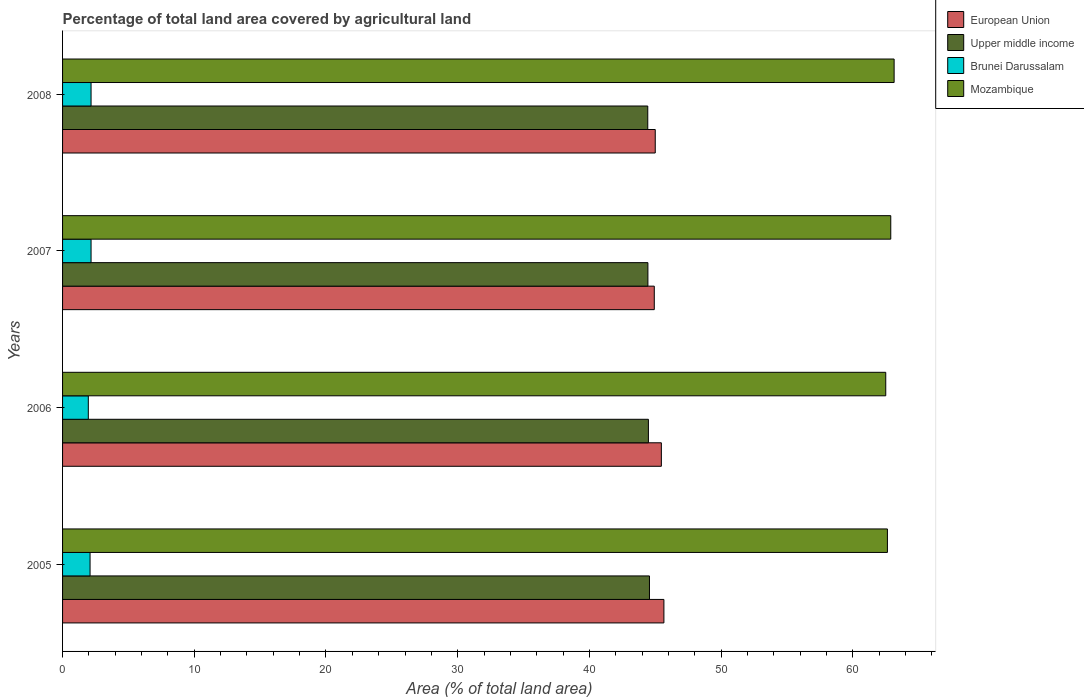How many different coloured bars are there?
Make the answer very short. 4. How many bars are there on the 1st tick from the top?
Make the answer very short. 4. How many bars are there on the 3rd tick from the bottom?
Offer a terse response. 4. In how many cases, is the number of bars for a given year not equal to the number of legend labels?
Offer a terse response. 0. What is the percentage of agricultural land in European Union in 2007?
Offer a very short reply. 44.93. Across all years, what is the maximum percentage of agricultural land in Brunei Darussalam?
Your answer should be very brief. 2.16. Across all years, what is the minimum percentage of agricultural land in European Union?
Your answer should be very brief. 44.93. In which year was the percentage of agricultural land in European Union maximum?
Give a very brief answer. 2005. In which year was the percentage of agricultural land in Mozambique minimum?
Keep it short and to the point. 2006. What is the total percentage of agricultural land in Brunei Darussalam in the graph?
Give a very brief answer. 8.37. What is the difference between the percentage of agricultural land in European Union in 2005 and that in 2008?
Your answer should be compact. 0.66. What is the difference between the percentage of agricultural land in European Union in 2006 and the percentage of agricultural land in Upper middle income in 2008?
Ensure brevity in your answer.  1.03. What is the average percentage of agricultural land in Mozambique per year?
Your answer should be very brief. 62.79. In the year 2006, what is the difference between the percentage of agricultural land in Brunei Darussalam and percentage of agricultural land in Mozambique?
Keep it short and to the point. -60.55. In how many years, is the percentage of agricultural land in Upper middle income greater than 24 %?
Keep it short and to the point. 4. What is the ratio of the percentage of agricultural land in Mozambique in 2006 to that in 2007?
Offer a very short reply. 0.99. Is the percentage of agricultural land in European Union in 2006 less than that in 2008?
Give a very brief answer. No. What is the difference between the highest and the second highest percentage of agricultural land in Upper middle income?
Offer a terse response. 0.08. What is the difference between the highest and the lowest percentage of agricultural land in Brunei Darussalam?
Offer a very short reply. 0.21. What does the 3rd bar from the top in 2007 represents?
Your answer should be compact. Upper middle income. What does the 3rd bar from the bottom in 2005 represents?
Your answer should be very brief. Brunei Darussalam. Is it the case that in every year, the sum of the percentage of agricultural land in Mozambique and percentage of agricultural land in Brunei Darussalam is greater than the percentage of agricultural land in Upper middle income?
Make the answer very short. Yes. How many bars are there?
Your answer should be compact. 16. Are all the bars in the graph horizontal?
Provide a succinct answer. Yes. Are the values on the major ticks of X-axis written in scientific E-notation?
Ensure brevity in your answer.  No. Does the graph contain any zero values?
Provide a succinct answer. No. Does the graph contain grids?
Provide a short and direct response. No. How many legend labels are there?
Provide a succinct answer. 4. How are the legend labels stacked?
Your answer should be compact. Vertical. What is the title of the graph?
Ensure brevity in your answer.  Percentage of total land area covered by agricultural land. Does "Tanzania" appear as one of the legend labels in the graph?
Provide a succinct answer. No. What is the label or title of the X-axis?
Give a very brief answer. Area (% of total land area). What is the Area (% of total land area) of European Union in 2005?
Your response must be concise. 45.66. What is the Area (% of total land area) of Upper middle income in 2005?
Provide a short and direct response. 44.56. What is the Area (% of total land area) in Brunei Darussalam in 2005?
Offer a terse response. 2.09. What is the Area (% of total land area) in Mozambique in 2005?
Provide a succinct answer. 62.63. What is the Area (% of total land area) in European Union in 2006?
Make the answer very short. 45.47. What is the Area (% of total land area) of Upper middle income in 2006?
Keep it short and to the point. 44.48. What is the Area (% of total land area) of Brunei Darussalam in 2006?
Give a very brief answer. 1.95. What is the Area (% of total land area) in Mozambique in 2006?
Provide a short and direct response. 62.5. What is the Area (% of total land area) of European Union in 2007?
Your answer should be very brief. 44.93. What is the Area (% of total land area) in Upper middle income in 2007?
Your answer should be very brief. 44.44. What is the Area (% of total land area) of Brunei Darussalam in 2007?
Provide a succinct answer. 2.16. What is the Area (% of total land area) in Mozambique in 2007?
Provide a short and direct response. 62.88. What is the Area (% of total land area) in European Union in 2008?
Ensure brevity in your answer.  45. What is the Area (% of total land area) of Upper middle income in 2008?
Give a very brief answer. 44.43. What is the Area (% of total land area) in Brunei Darussalam in 2008?
Offer a very short reply. 2.16. What is the Area (% of total land area) of Mozambique in 2008?
Make the answer very short. 63.14. Across all years, what is the maximum Area (% of total land area) of European Union?
Give a very brief answer. 45.66. Across all years, what is the maximum Area (% of total land area) of Upper middle income?
Offer a very short reply. 44.56. Across all years, what is the maximum Area (% of total land area) of Brunei Darussalam?
Give a very brief answer. 2.16. Across all years, what is the maximum Area (% of total land area) in Mozambique?
Provide a short and direct response. 63.14. Across all years, what is the minimum Area (% of total land area) in European Union?
Your answer should be very brief. 44.93. Across all years, what is the minimum Area (% of total land area) of Upper middle income?
Give a very brief answer. 44.43. Across all years, what is the minimum Area (% of total land area) in Brunei Darussalam?
Provide a short and direct response. 1.95. Across all years, what is the minimum Area (% of total land area) of Mozambique?
Provide a succinct answer. 62.5. What is the total Area (% of total land area) of European Union in the graph?
Your answer should be compact. 181.05. What is the total Area (% of total land area) in Upper middle income in the graph?
Your response must be concise. 177.92. What is the total Area (% of total land area) in Brunei Darussalam in the graph?
Provide a succinct answer. 8.37. What is the total Area (% of total land area) of Mozambique in the graph?
Provide a succinct answer. 251.15. What is the difference between the Area (% of total land area) in European Union in 2005 and that in 2006?
Provide a succinct answer. 0.19. What is the difference between the Area (% of total land area) in Upper middle income in 2005 and that in 2006?
Provide a short and direct response. 0.08. What is the difference between the Area (% of total land area) of Brunei Darussalam in 2005 and that in 2006?
Offer a very short reply. 0.13. What is the difference between the Area (% of total land area) in Mozambique in 2005 and that in 2006?
Offer a terse response. 0.13. What is the difference between the Area (% of total land area) in European Union in 2005 and that in 2007?
Ensure brevity in your answer.  0.73. What is the difference between the Area (% of total land area) of Upper middle income in 2005 and that in 2007?
Keep it short and to the point. 0.12. What is the difference between the Area (% of total land area) of Brunei Darussalam in 2005 and that in 2007?
Ensure brevity in your answer.  -0.08. What is the difference between the Area (% of total land area) of Mozambique in 2005 and that in 2007?
Make the answer very short. -0.25. What is the difference between the Area (% of total land area) of European Union in 2005 and that in 2008?
Your answer should be compact. 0.66. What is the difference between the Area (% of total land area) in Upper middle income in 2005 and that in 2008?
Ensure brevity in your answer.  0.13. What is the difference between the Area (% of total land area) of Brunei Darussalam in 2005 and that in 2008?
Your response must be concise. -0.08. What is the difference between the Area (% of total land area) of Mozambique in 2005 and that in 2008?
Provide a succinct answer. -0.51. What is the difference between the Area (% of total land area) of European Union in 2006 and that in 2007?
Offer a very short reply. 0.54. What is the difference between the Area (% of total land area) of Upper middle income in 2006 and that in 2007?
Your response must be concise. 0.04. What is the difference between the Area (% of total land area) in Brunei Darussalam in 2006 and that in 2007?
Your answer should be compact. -0.21. What is the difference between the Area (% of total land area) in Mozambique in 2006 and that in 2007?
Make the answer very short. -0.38. What is the difference between the Area (% of total land area) in European Union in 2006 and that in 2008?
Provide a succinct answer. 0.46. What is the difference between the Area (% of total land area) in Upper middle income in 2006 and that in 2008?
Your response must be concise. 0.05. What is the difference between the Area (% of total land area) in Brunei Darussalam in 2006 and that in 2008?
Keep it short and to the point. -0.21. What is the difference between the Area (% of total land area) in Mozambique in 2006 and that in 2008?
Your answer should be compact. -0.64. What is the difference between the Area (% of total land area) of European Union in 2007 and that in 2008?
Offer a terse response. -0.07. What is the difference between the Area (% of total land area) of Upper middle income in 2007 and that in 2008?
Offer a terse response. 0.01. What is the difference between the Area (% of total land area) in Brunei Darussalam in 2007 and that in 2008?
Ensure brevity in your answer.  0. What is the difference between the Area (% of total land area) in Mozambique in 2007 and that in 2008?
Your response must be concise. -0.25. What is the difference between the Area (% of total land area) in European Union in 2005 and the Area (% of total land area) in Upper middle income in 2006?
Ensure brevity in your answer.  1.18. What is the difference between the Area (% of total land area) of European Union in 2005 and the Area (% of total land area) of Brunei Darussalam in 2006?
Provide a succinct answer. 43.7. What is the difference between the Area (% of total land area) in European Union in 2005 and the Area (% of total land area) in Mozambique in 2006?
Make the answer very short. -16.84. What is the difference between the Area (% of total land area) of Upper middle income in 2005 and the Area (% of total land area) of Brunei Darussalam in 2006?
Make the answer very short. 42.61. What is the difference between the Area (% of total land area) of Upper middle income in 2005 and the Area (% of total land area) of Mozambique in 2006?
Offer a terse response. -17.94. What is the difference between the Area (% of total land area) of Brunei Darussalam in 2005 and the Area (% of total land area) of Mozambique in 2006?
Your answer should be compact. -60.41. What is the difference between the Area (% of total land area) of European Union in 2005 and the Area (% of total land area) of Upper middle income in 2007?
Offer a very short reply. 1.21. What is the difference between the Area (% of total land area) of European Union in 2005 and the Area (% of total land area) of Brunei Darussalam in 2007?
Provide a short and direct response. 43.49. What is the difference between the Area (% of total land area) in European Union in 2005 and the Area (% of total land area) in Mozambique in 2007?
Ensure brevity in your answer.  -17.23. What is the difference between the Area (% of total land area) of Upper middle income in 2005 and the Area (% of total land area) of Brunei Darussalam in 2007?
Your response must be concise. 42.4. What is the difference between the Area (% of total land area) of Upper middle income in 2005 and the Area (% of total land area) of Mozambique in 2007?
Your response must be concise. -18.32. What is the difference between the Area (% of total land area) of Brunei Darussalam in 2005 and the Area (% of total land area) of Mozambique in 2007?
Make the answer very short. -60.8. What is the difference between the Area (% of total land area) of European Union in 2005 and the Area (% of total land area) of Upper middle income in 2008?
Give a very brief answer. 1.23. What is the difference between the Area (% of total land area) of European Union in 2005 and the Area (% of total land area) of Brunei Darussalam in 2008?
Provide a succinct answer. 43.49. What is the difference between the Area (% of total land area) of European Union in 2005 and the Area (% of total land area) of Mozambique in 2008?
Ensure brevity in your answer.  -17.48. What is the difference between the Area (% of total land area) of Upper middle income in 2005 and the Area (% of total land area) of Brunei Darussalam in 2008?
Keep it short and to the point. 42.4. What is the difference between the Area (% of total land area) in Upper middle income in 2005 and the Area (% of total land area) in Mozambique in 2008?
Offer a very short reply. -18.58. What is the difference between the Area (% of total land area) of Brunei Darussalam in 2005 and the Area (% of total land area) of Mozambique in 2008?
Make the answer very short. -61.05. What is the difference between the Area (% of total land area) of European Union in 2006 and the Area (% of total land area) of Upper middle income in 2007?
Make the answer very short. 1.02. What is the difference between the Area (% of total land area) of European Union in 2006 and the Area (% of total land area) of Brunei Darussalam in 2007?
Keep it short and to the point. 43.3. What is the difference between the Area (% of total land area) in European Union in 2006 and the Area (% of total land area) in Mozambique in 2007?
Ensure brevity in your answer.  -17.42. What is the difference between the Area (% of total land area) of Upper middle income in 2006 and the Area (% of total land area) of Brunei Darussalam in 2007?
Make the answer very short. 42.32. What is the difference between the Area (% of total land area) in Upper middle income in 2006 and the Area (% of total land area) in Mozambique in 2007?
Provide a succinct answer. -18.4. What is the difference between the Area (% of total land area) of Brunei Darussalam in 2006 and the Area (% of total land area) of Mozambique in 2007?
Give a very brief answer. -60.93. What is the difference between the Area (% of total land area) of European Union in 2006 and the Area (% of total land area) of Upper middle income in 2008?
Offer a terse response. 1.03. What is the difference between the Area (% of total land area) of European Union in 2006 and the Area (% of total land area) of Brunei Darussalam in 2008?
Keep it short and to the point. 43.3. What is the difference between the Area (% of total land area) of European Union in 2006 and the Area (% of total land area) of Mozambique in 2008?
Your response must be concise. -17.67. What is the difference between the Area (% of total land area) in Upper middle income in 2006 and the Area (% of total land area) in Brunei Darussalam in 2008?
Your answer should be compact. 42.32. What is the difference between the Area (% of total land area) in Upper middle income in 2006 and the Area (% of total land area) in Mozambique in 2008?
Your answer should be compact. -18.66. What is the difference between the Area (% of total land area) in Brunei Darussalam in 2006 and the Area (% of total land area) in Mozambique in 2008?
Provide a short and direct response. -61.18. What is the difference between the Area (% of total land area) in European Union in 2007 and the Area (% of total land area) in Upper middle income in 2008?
Keep it short and to the point. 0.5. What is the difference between the Area (% of total land area) in European Union in 2007 and the Area (% of total land area) in Brunei Darussalam in 2008?
Keep it short and to the point. 42.76. What is the difference between the Area (% of total land area) of European Union in 2007 and the Area (% of total land area) of Mozambique in 2008?
Your response must be concise. -18.21. What is the difference between the Area (% of total land area) in Upper middle income in 2007 and the Area (% of total land area) in Brunei Darussalam in 2008?
Ensure brevity in your answer.  42.28. What is the difference between the Area (% of total land area) in Upper middle income in 2007 and the Area (% of total land area) in Mozambique in 2008?
Make the answer very short. -18.69. What is the difference between the Area (% of total land area) of Brunei Darussalam in 2007 and the Area (% of total land area) of Mozambique in 2008?
Offer a very short reply. -60.97. What is the average Area (% of total land area) in European Union per year?
Your answer should be very brief. 45.26. What is the average Area (% of total land area) of Upper middle income per year?
Provide a succinct answer. 44.48. What is the average Area (% of total land area) of Brunei Darussalam per year?
Offer a terse response. 2.09. What is the average Area (% of total land area) of Mozambique per year?
Provide a short and direct response. 62.79. In the year 2005, what is the difference between the Area (% of total land area) in European Union and Area (% of total land area) in Upper middle income?
Offer a very short reply. 1.1. In the year 2005, what is the difference between the Area (% of total land area) in European Union and Area (% of total land area) in Brunei Darussalam?
Offer a very short reply. 43.57. In the year 2005, what is the difference between the Area (% of total land area) in European Union and Area (% of total land area) in Mozambique?
Your answer should be compact. -16.97. In the year 2005, what is the difference between the Area (% of total land area) of Upper middle income and Area (% of total land area) of Brunei Darussalam?
Make the answer very short. 42.47. In the year 2005, what is the difference between the Area (% of total land area) of Upper middle income and Area (% of total land area) of Mozambique?
Keep it short and to the point. -18.07. In the year 2005, what is the difference between the Area (% of total land area) in Brunei Darussalam and Area (% of total land area) in Mozambique?
Ensure brevity in your answer.  -60.54. In the year 2006, what is the difference between the Area (% of total land area) in European Union and Area (% of total land area) in Upper middle income?
Offer a very short reply. 0.98. In the year 2006, what is the difference between the Area (% of total land area) in European Union and Area (% of total land area) in Brunei Darussalam?
Your answer should be very brief. 43.51. In the year 2006, what is the difference between the Area (% of total land area) in European Union and Area (% of total land area) in Mozambique?
Make the answer very short. -17.04. In the year 2006, what is the difference between the Area (% of total land area) of Upper middle income and Area (% of total land area) of Brunei Darussalam?
Your response must be concise. 42.53. In the year 2006, what is the difference between the Area (% of total land area) of Upper middle income and Area (% of total land area) of Mozambique?
Offer a very short reply. -18.02. In the year 2006, what is the difference between the Area (% of total land area) in Brunei Darussalam and Area (% of total land area) in Mozambique?
Ensure brevity in your answer.  -60.55. In the year 2007, what is the difference between the Area (% of total land area) of European Union and Area (% of total land area) of Upper middle income?
Ensure brevity in your answer.  0.48. In the year 2007, what is the difference between the Area (% of total land area) of European Union and Area (% of total land area) of Brunei Darussalam?
Offer a very short reply. 42.76. In the year 2007, what is the difference between the Area (% of total land area) of European Union and Area (% of total land area) of Mozambique?
Provide a succinct answer. -17.96. In the year 2007, what is the difference between the Area (% of total land area) of Upper middle income and Area (% of total land area) of Brunei Darussalam?
Your answer should be very brief. 42.28. In the year 2007, what is the difference between the Area (% of total land area) of Upper middle income and Area (% of total land area) of Mozambique?
Your answer should be compact. -18.44. In the year 2007, what is the difference between the Area (% of total land area) of Brunei Darussalam and Area (% of total land area) of Mozambique?
Give a very brief answer. -60.72. In the year 2008, what is the difference between the Area (% of total land area) of European Union and Area (% of total land area) of Upper middle income?
Offer a terse response. 0.57. In the year 2008, what is the difference between the Area (% of total land area) of European Union and Area (% of total land area) of Brunei Darussalam?
Your answer should be very brief. 42.84. In the year 2008, what is the difference between the Area (% of total land area) in European Union and Area (% of total land area) in Mozambique?
Provide a short and direct response. -18.14. In the year 2008, what is the difference between the Area (% of total land area) in Upper middle income and Area (% of total land area) in Brunei Darussalam?
Your answer should be very brief. 42.27. In the year 2008, what is the difference between the Area (% of total land area) in Upper middle income and Area (% of total land area) in Mozambique?
Your answer should be very brief. -18.71. In the year 2008, what is the difference between the Area (% of total land area) of Brunei Darussalam and Area (% of total land area) of Mozambique?
Ensure brevity in your answer.  -60.97. What is the ratio of the Area (% of total land area) in European Union in 2005 to that in 2006?
Offer a very short reply. 1. What is the ratio of the Area (% of total land area) in Upper middle income in 2005 to that in 2006?
Your response must be concise. 1. What is the ratio of the Area (% of total land area) of Brunei Darussalam in 2005 to that in 2006?
Give a very brief answer. 1.07. What is the ratio of the Area (% of total land area) in Mozambique in 2005 to that in 2006?
Offer a very short reply. 1. What is the ratio of the Area (% of total land area) of European Union in 2005 to that in 2007?
Ensure brevity in your answer.  1.02. What is the ratio of the Area (% of total land area) in Upper middle income in 2005 to that in 2007?
Your answer should be compact. 1. What is the ratio of the Area (% of total land area) in Brunei Darussalam in 2005 to that in 2007?
Offer a terse response. 0.96. What is the ratio of the Area (% of total land area) of Mozambique in 2005 to that in 2007?
Give a very brief answer. 1. What is the ratio of the Area (% of total land area) of European Union in 2005 to that in 2008?
Keep it short and to the point. 1.01. What is the ratio of the Area (% of total land area) in Upper middle income in 2005 to that in 2008?
Provide a short and direct response. 1. What is the ratio of the Area (% of total land area) of Brunei Darussalam in 2005 to that in 2008?
Provide a succinct answer. 0.96. What is the ratio of the Area (% of total land area) in Mozambique in 2005 to that in 2008?
Your answer should be very brief. 0.99. What is the ratio of the Area (% of total land area) of European Union in 2006 to that in 2007?
Your answer should be compact. 1.01. What is the ratio of the Area (% of total land area) in Upper middle income in 2006 to that in 2007?
Provide a succinct answer. 1. What is the ratio of the Area (% of total land area) in Brunei Darussalam in 2006 to that in 2007?
Ensure brevity in your answer.  0.9. What is the ratio of the Area (% of total land area) in European Union in 2006 to that in 2008?
Give a very brief answer. 1.01. What is the ratio of the Area (% of total land area) in Brunei Darussalam in 2006 to that in 2008?
Your answer should be very brief. 0.9. What is the ratio of the Area (% of total land area) of European Union in 2007 to that in 2008?
Give a very brief answer. 1. What is the ratio of the Area (% of total land area) of Upper middle income in 2007 to that in 2008?
Keep it short and to the point. 1. What is the difference between the highest and the second highest Area (% of total land area) of European Union?
Your answer should be compact. 0.19. What is the difference between the highest and the second highest Area (% of total land area) in Upper middle income?
Offer a very short reply. 0.08. What is the difference between the highest and the second highest Area (% of total land area) of Brunei Darussalam?
Give a very brief answer. 0. What is the difference between the highest and the second highest Area (% of total land area) of Mozambique?
Make the answer very short. 0.25. What is the difference between the highest and the lowest Area (% of total land area) in European Union?
Your response must be concise. 0.73. What is the difference between the highest and the lowest Area (% of total land area) in Upper middle income?
Keep it short and to the point. 0.13. What is the difference between the highest and the lowest Area (% of total land area) in Brunei Darussalam?
Make the answer very short. 0.21. What is the difference between the highest and the lowest Area (% of total land area) of Mozambique?
Your answer should be compact. 0.64. 